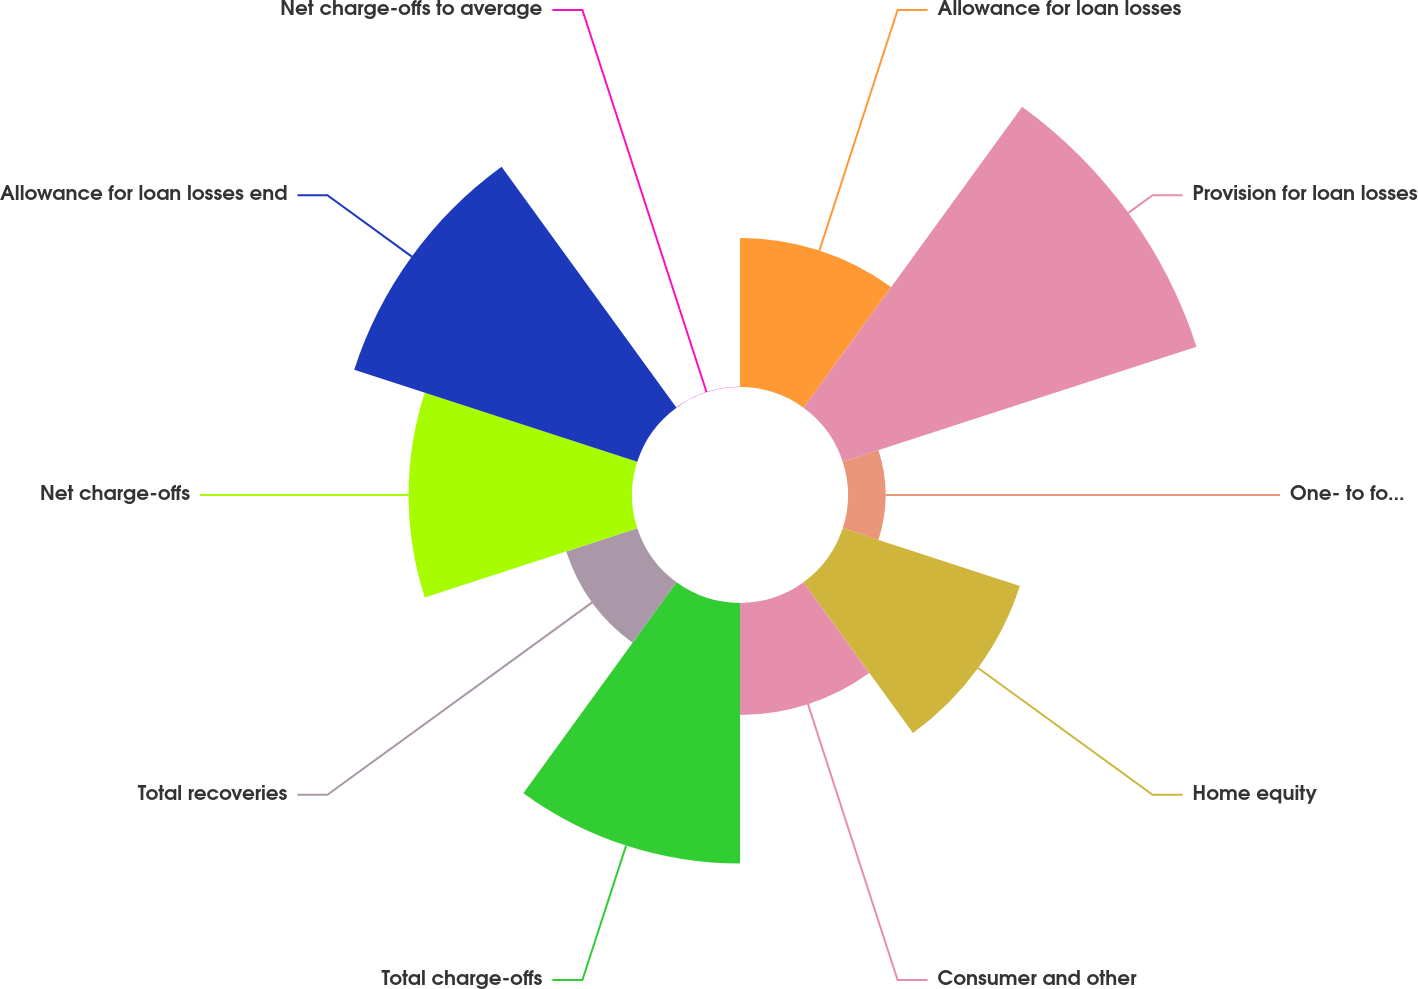Convert chart to OTSL. <chart><loc_0><loc_0><loc_500><loc_500><pie_chart><fcel>Allowance for loan losses<fcel>Provision for loan losses<fcel>One- to four-family<fcel>Home equity<fcel>Consumer and other<fcel>Total charge-offs<fcel>Total recoveries<fcel>Net charge-offs<fcel>Allowance for loan losses end<fcel>Net charge-offs to average<nl><fcel>8.7%<fcel>21.71%<fcel>2.19%<fcel>10.87%<fcel>6.53%<fcel>15.21%<fcel>4.36%<fcel>13.04%<fcel>17.37%<fcel>0.02%<nl></chart> 